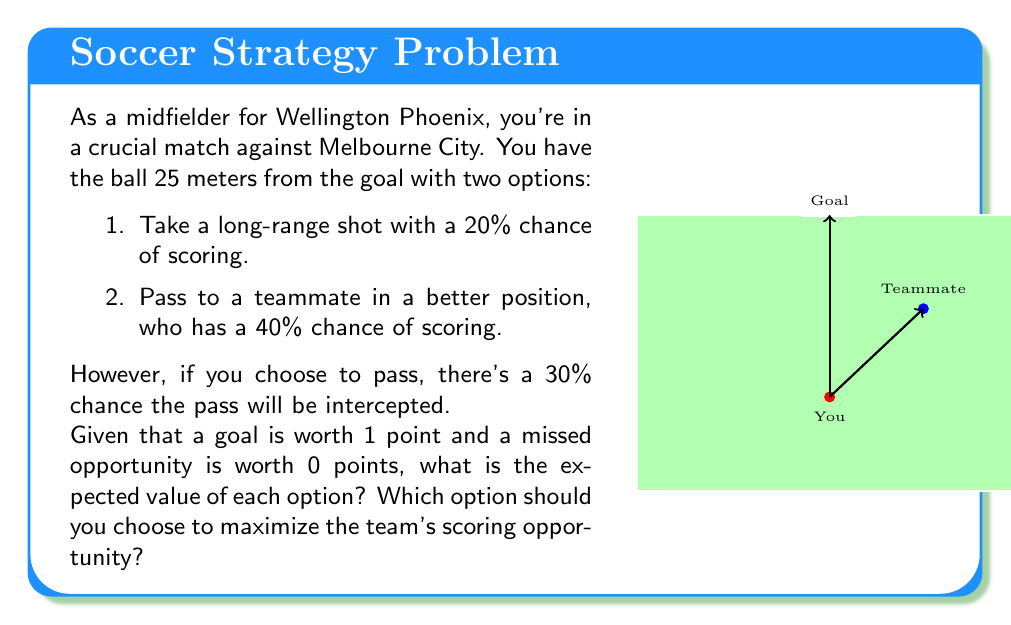Can you solve this math problem? Let's break this down step-by-step:

1) Option 1: Long-range shot
   - Probability of scoring: 20% = 0.2
   - Expected value: $EV_1 = 0.2 \times 1 + 0.8 \times 0 = 0.2$

2) Option 2: Pass to teammate
   - Probability of successful pass: 70% = 0.7 (since 30% chance of interception)
   - If pass is successful, teammate has 40% chance of scoring
   - Expected value: 
     $$EV_2 = 0.7 \times (0.4 \times 1 + 0.6 \times 0) + 0.3 \times 0$$
     $$EV_2 = 0.7 \times 0.4 = 0.28$$

3) Comparing the two options:
   - Option 1 (shot): $EV_1 = 0.2$
   - Option 2 (pass): $EV_2 = 0.28$

4) Decision:
   Since $EV_2 > EV_1$, the optimal choice is to pass to the teammate.

This decision maximizes the expected value of the scoring opportunity for the team.
Answer: Pass to teammate; $EV_{pass} = 0.28 > EV_{shot} = 0.2$ 